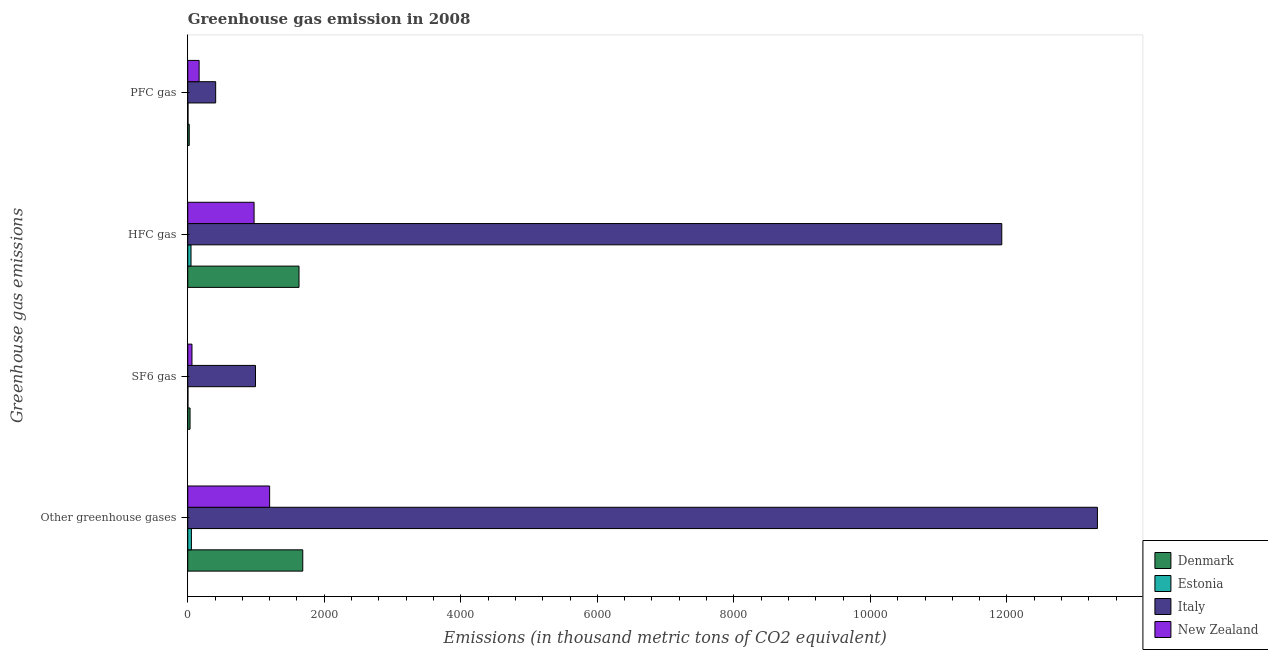How many different coloured bars are there?
Keep it short and to the point. 4. How many groups of bars are there?
Make the answer very short. 4. How many bars are there on the 2nd tick from the bottom?
Provide a succinct answer. 4. What is the label of the 2nd group of bars from the top?
Offer a very short reply. HFC gas. What is the emission of pfc gas in Denmark?
Your answer should be compact. 21.4. Across all countries, what is the maximum emission of hfc gas?
Keep it short and to the point. 1.19e+04. In which country was the emission of greenhouse gases minimum?
Keep it short and to the point. Estonia. What is the total emission of pfc gas in the graph?
Provide a succinct answer. 600. What is the difference between the emission of hfc gas in Italy and that in New Zealand?
Your answer should be very brief. 1.10e+04. What is the difference between the emission of hfc gas in Estonia and the emission of pfc gas in Italy?
Give a very brief answer. -361.2. What is the average emission of greenhouse gases per country?
Make the answer very short. 4065.62. What is the difference between the emission of sf6 gas and emission of hfc gas in Denmark?
Your answer should be compact. -1596.1. What is the ratio of the emission of greenhouse gases in Estonia to that in New Zealand?
Give a very brief answer. 0.04. Is the difference between the emission of sf6 gas in Denmark and Italy greater than the difference between the emission of greenhouse gases in Denmark and Italy?
Your response must be concise. Yes. What is the difference between the highest and the second highest emission of hfc gas?
Keep it short and to the point. 1.03e+04. What is the difference between the highest and the lowest emission of greenhouse gases?
Provide a succinct answer. 1.33e+04. Is the sum of the emission of pfc gas in New Zealand and Italy greater than the maximum emission of hfc gas across all countries?
Offer a very short reply. No. What does the 1st bar from the top in Other greenhouse gases represents?
Keep it short and to the point. New Zealand. How many countries are there in the graph?
Keep it short and to the point. 4. Are the values on the major ticks of X-axis written in scientific E-notation?
Your answer should be very brief. No. Does the graph contain grids?
Provide a short and direct response. No. Where does the legend appear in the graph?
Your answer should be very brief. Bottom right. How are the legend labels stacked?
Make the answer very short. Vertical. What is the title of the graph?
Provide a succinct answer. Greenhouse gas emission in 2008. What is the label or title of the X-axis?
Offer a terse response. Emissions (in thousand metric tons of CO2 equivalent). What is the label or title of the Y-axis?
Provide a short and direct response. Greenhouse gas emissions. What is the Emissions (in thousand metric tons of CO2 equivalent) of Denmark in Other greenhouse gases?
Your answer should be compact. 1684.5. What is the Emissions (in thousand metric tons of CO2 equivalent) of Estonia in Other greenhouse gases?
Offer a very short reply. 53.3. What is the Emissions (in thousand metric tons of CO2 equivalent) of Italy in Other greenhouse gases?
Offer a terse response. 1.33e+04. What is the Emissions (in thousand metric tons of CO2 equivalent) in New Zealand in Other greenhouse gases?
Offer a very short reply. 1199.3. What is the Emissions (in thousand metric tons of CO2 equivalent) of Denmark in SF6 gas?
Your answer should be very brief. 33.5. What is the Emissions (in thousand metric tons of CO2 equivalent) of Estonia in SF6 gas?
Provide a succinct answer. 2.3. What is the Emissions (in thousand metric tons of CO2 equivalent) in Italy in SF6 gas?
Make the answer very short. 992.1. What is the Emissions (in thousand metric tons of CO2 equivalent) of New Zealand in SF6 gas?
Offer a very short reply. 61.5. What is the Emissions (in thousand metric tons of CO2 equivalent) in Denmark in HFC gas?
Offer a very short reply. 1629.6. What is the Emissions (in thousand metric tons of CO2 equivalent) of Estonia in HFC gas?
Provide a succinct answer. 47.6. What is the Emissions (in thousand metric tons of CO2 equivalent) of Italy in HFC gas?
Provide a short and direct response. 1.19e+04. What is the Emissions (in thousand metric tons of CO2 equivalent) of New Zealand in HFC gas?
Provide a short and direct response. 971.4. What is the Emissions (in thousand metric tons of CO2 equivalent) of Denmark in PFC gas?
Give a very brief answer. 21.4. What is the Emissions (in thousand metric tons of CO2 equivalent) of Italy in PFC gas?
Offer a very short reply. 408.8. What is the Emissions (in thousand metric tons of CO2 equivalent) of New Zealand in PFC gas?
Provide a short and direct response. 166.4. Across all Greenhouse gas emissions, what is the maximum Emissions (in thousand metric tons of CO2 equivalent) of Denmark?
Your answer should be compact. 1684.5. Across all Greenhouse gas emissions, what is the maximum Emissions (in thousand metric tons of CO2 equivalent) in Estonia?
Provide a short and direct response. 53.3. Across all Greenhouse gas emissions, what is the maximum Emissions (in thousand metric tons of CO2 equivalent) in Italy?
Your answer should be very brief. 1.33e+04. Across all Greenhouse gas emissions, what is the maximum Emissions (in thousand metric tons of CO2 equivalent) in New Zealand?
Your response must be concise. 1199.3. Across all Greenhouse gas emissions, what is the minimum Emissions (in thousand metric tons of CO2 equivalent) of Denmark?
Offer a terse response. 21.4. Across all Greenhouse gas emissions, what is the minimum Emissions (in thousand metric tons of CO2 equivalent) in Estonia?
Keep it short and to the point. 2.3. Across all Greenhouse gas emissions, what is the minimum Emissions (in thousand metric tons of CO2 equivalent) in Italy?
Offer a terse response. 408.8. Across all Greenhouse gas emissions, what is the minimum Emissions (in thousand metric tons of CO2 equivalent) of New Zealand?
Make the answer very short. 61.5. What is the total Emissions (in thousand metric tons of CO2 equivalent) of Denmark in the graph?
Give a very brief answer. 3369. What is the total Emissions (in thousand metric tons of CO2 equivalent) of Estonia in the graph?
Give a very brief answer. 106.6. What is the total Emissions (in thousand metric tons of CO2 equivalent) in Italy in the graph?
Give a very brief answer. 2.67e+04. What is the total Emissions (in thousand metric tons of CO2 equivalent) of New Zealand in the graph?
Give a very brief answer. 2398.6. What is the difference between the Emissions (in thousand metric tons of CO2 equivalent) in Denmark in Other greenhouse gases and that in SF6 gas?
Offer a terse response. 1651. What is the difference between the Emissions (in thousand metric tons of CO2 equivalent) in Italy in Other greenhouse gases and that in SF6 gas?
Provide a short and direct response. 1.23e+04. What is the difference between the Emissions (in thousand metric tons of CO2 equivalent) of New Zealand in Other greenhouse gases and that in SF6 gas?
Make the answer very short. 1137.8. What is the difference between the Emissions (in thousand metric tons of CO2 equivalent) of Denmark in Other greenhouse gases and that in HFC gas?
Keep it short and to the point. 54.9. What is the difference between the Emissions (in thousand metric tons of CO2 equivalent) of Italy in Other greenhouse gases and that in HFC gas?
Provide a succinct answer. 1400.9. What is the difference between the Emissions (in thousand metric tons of CO2 equivalent) in New Zealand in Other greenhouse gases and that in HFC gas?
Offer a terse response. 227.9. What is the difference between the Emissions (in thousand metric tons of CO2 equivalent) of Denmark in Other greenhouse gases and that in PFC gas?
Keep it short and to the point. 1663.1. What is the difference between the Emissions (in thousand metric tons of CO2 equivalent) in Estonia in Other greenhouse gases and that in PFC gas?
Provide a succinct answer. 49.9. What is the difference between the Emissions (in thousand metric tons of CO2 equivalent) in Italy in Other greenhouse gases and that in PFC gas?
Your answer should be compact. 1.29e+04. What is the difference between the Emissions (in thousand metric tons of CO2 equivalent) of New Zealand in Other greenhouse gases and that in PFC gas?
Offer a very short reply. 1032.9. What is the difference between the Emissions (in thousand metric tons of CO2 equivalent) in Denmark in SF6 gas and that in HFC gas?
Provide a short and direct response. -1596.1. What is the difference between the Emissions (in thousand metric tons of CO2 equivalent) of Estonia in SF6 gas and that in HFC gas?
Provide a succinct answer. -45.3. What is the difference between the Emissions (in thousand metric tons of CO2 equivalent) in Italy in SF6 gas and that in HFC gas?
Make the answer very short. -1.09e+04. What is the difference between the Emissions (in thousand metric tons of CO2 equivalent) of New Zealand in SF6 gas and that in HFC gas?
Your answer should be compact. -909.9. What is the difference between the Emissions (in thousand metric tons of CO2 equivalent) in Italy in SF6 gas and that in PFC gas?
Provide a succinct answer. 583.3. What is the difference between the Emissions (in thousand metric tons of CO2 equivalent) in New Zealand in SF6 gas and that in PFC gas?
Make the answer very short. -104.9. What is the difference between the Emissions (in thousand metric tons of CO2 equivalent) of Denmark in HFC gas and that in PFC gas?
Offer a very short reply. 1608.2. What is the difference between the Emissions (in thousand metric tons of CO2 equivalent) of Estonia in HFC gas and that in PFC gas?
Keep it short and to the point. 44.2. What is the difference between the Emissions (in thousand metric tons of CO2 equivalent) in Italy in HFC gas and that in PFC gas?
Keep it short and to the point. 1.15e+04. What is the difference between the Emissions (in thousand metric tons of CO2 equivalent) of New Zealand in HFC gas and that in PFC gas?
Your response must be concise. 805. What is the difference between the Emissions (in thousand metric tons of CO2 equivalent) in Denmark in Other greenhouse gases and the Emissions (in thousand metric tons of CO2 equivalent) in Estonia in SF6 gas?
Keep it short and to the point. 1682.2. What is the difference between the Emissions (in thousand metric tons of CO2 equivalent) of Denmark in Other greenhouse gases and the Emissions (in thousand metric tons of CO2 equivalent) of Italy in SF6 gas?
Ensure brevity in your answer.  692.4. What is the difference between the Emissions (in thousand metric tons of CO2 equivalent) in Denmark in Other greenhouse gases and the Emissions (in thousand metric tons of CO2 equivalent) in New Zealand in SF6 gas?
Give a very brief answer. 1623. What is the difference between the Emissions (in thousand metric tons of CO2 equivalent) of Estonia in Other greenhouse gases and the Emissions (in thousand metric tons of CO2 equivalent) of Italy in SF6 gas?
Offer a very short reply. -938.8. What is the difference between the Emissions (in thousand metric tons of CO2 equivalent) in Italy in Other greenhouse gases and the Emissions (in thousand metric tons of CO2 equivalent) in New Zealand in SF6 gas?
Offer a very short reply. 1.33e+04. What is the difference between the Emissions (in thousand metric tons of CO2 equivalent) of Denmark in Other greenhouse gases and the Emissions (in thousand metric tons of CO2 equivalent) of Estonia in HFC gas?
Offer a terse response. 1636.9. What is the difference between the Emissions (in thousand metric tons of CO2 equivalent) in Denmark in Other greenhouse gases and the Emissions (in thousand metric tons of CO2 equivalent) in Italy in HFC gas?
Provide a succinct answer. -1.02e+04. What is the difference between the Emissions (in thousand metric tons of CO2 equivalent) in Denmark in Other greenhouse gases and the Emissions (in thousand metric tons of CO2 equivalent) in New Zealand in HFC gas?
Keep it short and to the point. 713.1. What is the difference between the Emissions (in thousand metric tons of CO2 equivalent) of Estonia in Other greenhouse gases and the Emissions (in thousand metric tons of CO2 equivalent) of Italy in HFC gas?
Keep it short and to the point. -1.19e+04. What is the difference between the Emissions (in thousand metric tons of CO2 equivalent) of Estonia in Other greenhouse gases and the Emissions (in thousand metric tons of CO2 equivalent) of New Zealand in HFC gas?
Your answer should be very brief. -918.1. What is the difference between the Emissions (in thousand metric tons of CO2 equivalent) of Italy in Other greenhouse gases and the Emissions (in thousand metric tons of CO2 equivalent) of New Zealand in HFC gas?
Offer a very short reply. 1.24e+04. What is the difference between the Emissions (in thousand metric tons of CO2 equivalent) in Denmark in Other greenhouse gases and the Emissions (in thousand metric tons of CO2 equivalent) in Estonia in PFC gas?
Offer a very short reply. 1681.1. What is the difference between the Emissions (in thousand metric tons of CO2 equivalent) in Denmark in Other greenhouse gases and the Emissions (in thousand metric tons of CO2 equivalent) in Italy in PFC gas?
Your response must be concise. 1275.7. What is the difference between the Emissions (in thousand metric tons of CO2 equivalent) of Denmark in Other greenhouse gases and the Emissions (in thousand metric tons of CO2 equivalent) of New Zealand in PFC gas?
Make the answer very short. 1518.1. What is the difference between the Emissions (in thousand metric tons of CO2 equivalent) of Estonia in Other greenhouse gases and the Emissions (in thousand metric tons of CO2 equivalent) of Italy in PFC gas?
Provide a succinct answer. -355.5. What is the difference between the Emissions (in thousand metric tons of CO2 equivalent) of Estonia in Other greenhouse gases and the Emissions (in thousand metric tons of CO2 equivalent) of New Zealand in PFC gas?
Offer a terse response. -113.1. What is the difference between the Emissions (in thousand metric tons of CO2 equivalent) in Italy in Other greenhouse gases and the Emissions (in thousand metric tons of CO2 equivalent) in New Zealand in PFC gas?
Your answer should be very brief. 1.32e+04. What is the difference between the Emissions (in thousand metric tons of CO2 equivalent) in Denmark in SF6 gas and the Emissions (in thousand metric tons of CO2 equivalent) in Estonia in HFC gas?
Offer a terse response. -14.1. What is the difference between the Emissions (in thousand metric tons of CO2 equivalent) of Denmark in SF6 gas and the Emissions (in thousand metric tons of CO2 equivalent) of Italy in HFC gas?
Make the answer very short. -1.19e+04. What is the difference between the Emissions (in thousand metric tons of CO2 equivalent) of Denmark in SF6 gas and the Emissions (in thousand metric tons of CO2 equivalent) of New Zealand in HFC gas?
Offer a very short reply. -937.9. What is the difference between the Emissions (in thousand metric tons of CO2 equivalent) of Estonia in SF6 gas and the Emissions (in thousand metric tons of CO2 equivalent) of Italy in HFC gas?
Provide a short and direct response. -1.19e+04. What is the difference between the Emissions (in thousand metric tons of CO2 equivalent) of Estonia in SF6 gas and the Emissions (in thousand metric tons of CO2 equivalent) of New Zealand in HFC gas?
Keep it short and to the point. -969.1. What is the difference between the Emissions (in thousand metric tons of CO2 equivalent) of Italy in SF6 gas and the Emissions (in thousand metric tons of CO2 equivalent) of New Zealand in HFC gas?
Your answer should be very brief. 20.7. What is the difference between the Emissions (in thousand metric tons of CO2 equivalent) in Denmark in SF6 gas and the Emissions (in thousand metric tons of CO2 equivalent) in Estonia in PFC gas?
Offer a terse response. 30.1. What is the difference between the Emissions (in thousand metric tons of CO2 equivalent) in Denmark in SF6 gas and the Emissions (in thousand metric tons of CO2 equivalent) in Italy in PFC gas?
Keep it short and to the point. -375.3. What is the difference between the Emissions (in thousand metric tons of CO2 equivalent) of Denmark in SF6 gas and the Emissions (in thousand metric tons of CO2 equivalent) of New Zealand in PFC gas?
Offer a very short reply. -132.9. What is the difference between the Emissions (in thousand metric tons of CO2 equivalent) in Estonia in SF6 gas and the Emissions (in thousand metric tons of CO2 equivalent) in Italy in PFC gas?
Keep it short and to the point. -406.5. What is the difference between the Emissions (in thousand metric tons of CO2 equivalent) of Estonia in SF6 gas and the Emissions (in thousand metric tons of CO2 equivalent) of New Zealand in PFC gas?
Make the answer very short. -164.1. What is the difference between the Emissions (in thousand metric tons of CO2 equivalent) of Italy in SF6 gas and the Emissions (in thousand metric tons of CO2 equivalent) of New Zealand in PFC gas?
Provide a short and direct response. 825.7. What is the difference between the Emissions (in thousand metric tons of CO2 equivalent) in Denmark in HFC gas and the Emissions (in thousand metric tons of CO2 equivalent) in Estonia in PFC gas?
Ensure brevity in your answer.  1626.2. What is the difference between the Emissions (in thousand metric tons of CO2 equivalent) of Denmark in HFC gas and the Emissions (in thousand metric tons of CO2 equivalent) of Italy in PFC gas?
Provide a succinct answer. 1220.8. What is the difference between the Emissions (in thousand metric tons of CO2 equivalent) of Denmark in HFC gas and the Emissions (in thousand metric tons of CO2 equivalent) of New Zealand in PFC gas?
Offer a terse response. 1463.2. What is the difference between the Emissions (in thousand metric tons of CO2 equivalent) in Estonia in HFC gas and the Emissions (in thousand metric tons of CO2 equivalent) in Italy in PFC gas?
Your answer should be very brief. -361.2. What is the difference between the Emissions (in thousand metric tons of CO2 equivalent) in Estonia in HFC gas and the Emissions (in thousand metric tons of CO2 equivalent) in New Zealand in PFC gas?
Offer a terse response. -118.8. What is the difference between the Emissions (in thousand metric tons of CO2 equivalent) in Italy in HFC gas and the Emissions (in thousand metric tons of CO2 equivalent) in New Zealand in PFC gas?
Provide a short and direct response. 1.18e+04. What is the average Emissions (in thousand metric tons of CO2 equivalent) in Denmark per Greenhouse gas emissions?
Give a very brief answer. 842.25. What is the average Emissions (in thousand metric tons of CO2 equivalent) in Estonia per Greenhouse gas emissions?
Your answer should be very brief. 26.65. What is the average Emissions (in thousand metric tons of CO2 equivalent) in Italy per Greenhouse gas emissions?
Offer a very short reply. 6662.7. What is the average Emissions (in thousand metric tons of CO2 equivalent) of New Zealand per Greenhouse gas emissions?
Keep it short and to the point. 599.65. What is the difference between the Emissions (in thousand metric tons of CO2 equivalent) of Denmark and Emissions (in thousand metric tons of CO2 equivalent) of Estonia in Other greenhouse gases?
Provide a short and direct response. 1631.2. What is the difference between the Emissions (in thousand metric tons of CO2 equivalent) of Denmark and Emissions (in thousand metric tons of CO2 equivalent) of Italy in Other greenhouse gases?
Give a very brief answer. -1.16e+04. What is the difference between the Emissions (in thousand metric tons of CO2 equivalent) in Denmark and Emissions (in thousand metric tons of CO2 equivalent) in New Zealand in Other greenhouse gases?
Your answer should be compact. 485.2. What is the difference between the Emissions (in thousand metric tons of CO2 equivalent) of Estonia and Emissions (in thousand metric tons of CO2 equivalent) of Italy in Other greenhouse gases?
Provide a short and direct response. -1.33e+04. What is the difference between the Emissions (in thousand metric tons of CO2 equivalent) in Estonia and Emissions (in thousand metric tons of CO2 equivalent) in New Zealand in Other greenhouse gases?
Provide a succinct answer. -1146. What is the difference between the Emissions (in thousand metric tons of CO2 equivalent) in Italy and Emissions (in thousand metric tons of CO2 equivalent) in New Zealand in Other greenhouse gases?
Ensure brevity in your answer.  1.21e+04. What is the difference between the Emissions (in thousand metric tons of CO2 equivalent) in Denmark and Emissions (in thousand metric tons of CO2 equivalent) in Estonia in SF6 gas?
Provide a succinct answer. 31.2. What is the difference between the Emissions (in thousand metric tons of CO2 equivalent) in Denmark and Emissions (in thousand metric tons of CO2 equivalent) in Italy in SF6 gas?
Provide a short and direct response. -958.6. What is the difference between the Emissions (in thousand metric tons of CO2 equivalent) of Estonia and Emissions (in thousand metric tons of CO2 equivalent) of Italy in SF6 gas?
Give a very brief answer. -989.8. What is the difference between the Emissions (in thousand metric tons of CO2 equivalent) of Estonia and Emissions (in thousand metric tons of CO2 equivalent) of New Zealand in SF6 gas?
Your response must be concise. -59.2. What is the difference between the Emissions (in thousand metric tons of CO2 equivalent) in Italy and Emissions (in thousand metric tons of CO2 equivalent) in New Zealand in SF6 gas?
Your response must be concise. 930.6. What is the difference between the Emissions (in thousand metric tons of CO2 equivalent) of Denmark and Emissions (in thousand metric tons of CO2 equivalent) of Estonia in HFC gas?
Offer a terse response. 1582. What is the difference between the Emissions (in thousand metric tons of CO2 equivalent) of Denmark and Emissions (in thousand metric tons of CO2 equivalent) of Italy in HFC gas?
Your response must be concise. -1.03e+04. What is the difference between the Emissions (in thousand metric tons of CO2 equivalent) in Denmark and Emissions (in thousand metric tons of CO2 equivalent) in New Zealand in HFC gas?
Provide a short and direct response. 658.2. What is the difference between the Emissions (in thousand metric tons of CO2 equivalent) in Estonia and Emissions (in thousand metric tons of CO2 equivalent) in Italy in HFC gas?
Give a very brief answer. -1.19e+04. What is the difference between the Emissions (in thousand metric tons of CO2 equivalent) of Estonia and Emissions (in thousand metric tons of CO2 equivalent) of New Zealand in HFC gas?
Your answer should be compact. -923.8. What is the difference between the Emissions (in thousand metric tons of CO2 equivalent) in Italy and Emissions (in thousand metric tons of CO2 equivalent) in New Zealand in HFC gas?
Make the answer very short. 1.10e+04. What is the difference between the Emissions (in thousand metric tons of CO2 equivalent) in Denmark and Emissions (in thousand metric tons of CO2 equivalent) in Italy in PFC gas?
Ensure brevity in your answer.  -387.4. What is the difference between the Emissions (in thousand metric tons of CO2 equivalent) of Denmark and Emissions (in thousand metric tons of CO2 equivalent) of New Zealand in PFC gas?
Keep it short and to the point. -145. What is the difference between the Emissions (in thousand metric tons of CO2 equivalent) of Estonia and Emissions (in thousand metric tons of CO2 equivalent) of Italy in PFC gas?
Ensure brevity in your answer.  -405.4. What is the difference between the Emissions (in thousand metric tons of CO2 equivalent) in Estonia and Emissions (in thousand metric tons of CO2 equivalent) in New Zealand in PFC gas?
Give a very brief answer. -163. What is the difference between the Emissions (in thousand metric tons of CO2 equivalent) of Italy and Emissions (in thousand metric tons of CO2 equivalent) of New Zealand in PFC gas?
Your answer should be compact. 242.4. What is the ratio of the Emissions (in thousand metric tons of CO2 equivalent) of Denmark in Other greenhouse gases to that in SF6 gas?
Ensure brevity in your answer.  50.28. What is the ratio of the Emissions (in thousand metric tons of CO2 equivalent) in Estonia in Other greenhouse gases to that in SF6 gas?
Keep it short and to the point. 23.17. What is the ratio of the Emissions (in thousand metric tons of CO2 equivalent) in Italy in Other greenhouse gases to that in SF6 gas?
Provide a succinct answer. 13.43. What is the ratio of the Emissions (in thousand metric tons of CO2 equivalent) of New Zealand in Other greenhouse gases to that in SF6 gas?
Make the answer very short. 19.5. What is the ratio of the Emissions (in thousand metric tons of CO2 equivalent) of Denmark in Other greenhouse gases to that in HFC gas?
Provide a succinct answer. 1.03. What is the ratio of the Emissions (in thousand metric tons of CO2 equivalent) in Estonia in Other greenhouse gases to that in HFC gas?
Give a very brief answer. 1.12. What is the ratio of the Emissions (in thousand metric tons of CO2 equivalent) in Italy in Other greenhouse gases to that in HFC gas?
Offer a terse response. 1.12. What is the ratio of the Emissions (in thousand metric tons of CO2 equivalent) in New Zealand in Other greenhouse gases to that in HFC gas?
Keep it short and to the point. 1.23. What is the ratio of the Emissions (in thousand metric tons of CO2 equivalent) in Denmark in Other greenhouse gases to that in PFC gas?
Make the answer very short. 78.72. What is the ratio of the Emissions (in thousand metric tons of CO2 equivalent) in Estonia in Other greenhouse gases to that in PFC gas?
Keep it short and to the point. 15.68. What is the ratio of the Emissions (in thousand metric tons of CO2 equivalent) of Italy in Other greenhouse gases to that in PFC gas?
Your response must be concise. 32.6. What is the ratio of the Emissions (in thousand metric tons of CO2 equivalent) of New Zealand in Other greenhouse gases to that in PFC gas?
Give a very brief answer. 7.21. What is the ratio of the Emissions (in thousand metric tons of CO2 equivalent) in Denmark in SF6 gas to that in HFC gas?
Offer a terse response. 0.02. What is the ratio of the Emissions (in thousand metric tons of CO2 equivalent) of Estonia in SF6 gas to that in HFC gas?
Offer a terse response. 0.05. What is the ratio of the Emissions (in thousand metric tons of CO2 equivalent) of Italy in SF6 gas to that in HFC gas?
Make the answer very short. 0.08. What is the ratio of the Emissions (in thousand metric tons of CO2 equivalent) of New Zealand in SF6 gas to that in HFC gas?
Provide a short and direct response. 0.06. What is the ratio of the Emissions (in thousand metric tons of CO2 equivalent) of Denmark in SF6 gas to that in PFC gas?
Ensure brevity in your answer.  1.57. What is the ratio of the Emissions (in thousand metric tons of CO2 equivalent) of Estonia in SF6 gas to that in PFC gas?
Make the answer very short. 0.68. What is the ratio of the Emissions (in thousand metric tons of CO2 equivalent) of Italy in SF6 gas to that in PFC gas?
Your answer should be compact. 2.43. What is the ratio of the Emissions (in thousand metric tons of CO2 equivalent) in New Zealand in SF6 gas to that in PFC gas?
Offer a very short reply. 0.37. What is the ratio of the Emissions (in thousand metric tons of CO2 equivalent) of Denmark in HFC gas to that in PFC gas?
Your answer should be compact. 76.15. What is the ratio of the Emissions (in thousand metric tons of CO2 equivalent) of Italy in HFC gas to that in PFC gas?
Your answer should be very brief. 29.17. What is the ratio of the Emissions (in thousand metric tons of CO2 equivalent) of New Zealand in HFC gas to that in PFC gas?
Give a very brief answer. 5.84. What is the difference between the highest and the second highest Emissions (in thousand metric tons of CO2 equivalent) of Denmark?
Give a very brief answer. 54.9. What is the difference between the highest and the second highest Emissions (in thousand metric tons of CO2 equivalent) of Italy?
Keep it short and to the point. 1400.9. What is the difference between the highest and the second highest Emissions (in thousand metric tons of CO2 equivalent) in New Zealand?
Provide a short and direct response. 227.9. What is the difference between the highest and the lowest Emissions (in thousand metric tons of CO2 equivalent) in Denmark?
Offer a very short reply. 1663.1. What is the difference between the highest and the lowest Emissions (in thousand metric tons of CO2 equivalent) of Estonia?
Your response must be concise. 51. What is the difference between the highest and the lowest Emissions (in thousand metric tons of CO2 equivalent) of Italy?
Offer a terse response. 1.29e+04. What is the difference between the highest and the lowest Emissions (in thousand metric tons of CO2 equivalent) of New Zealand?
Your response must be concise. 1137.8. 